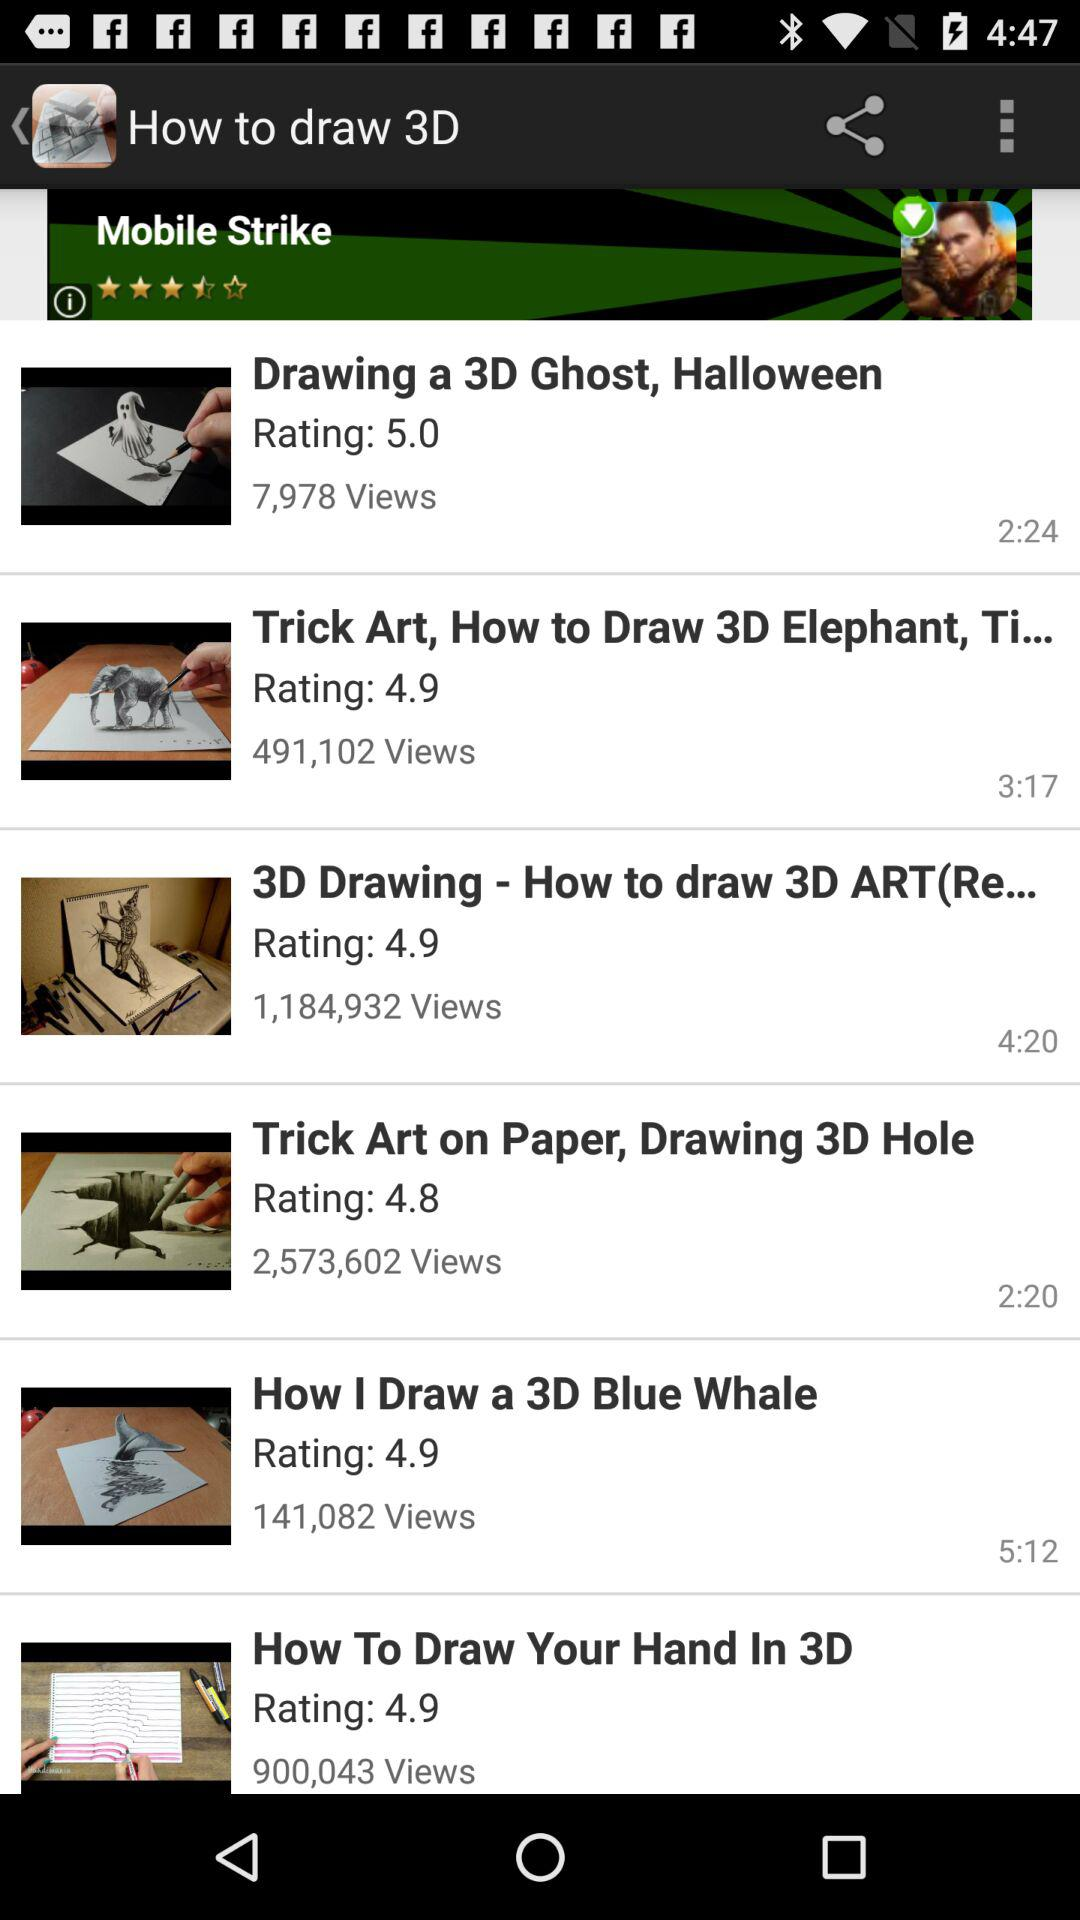The total number of views present on "How I Draw a 3D Blue Whale"? The total number of views is 141,082. 